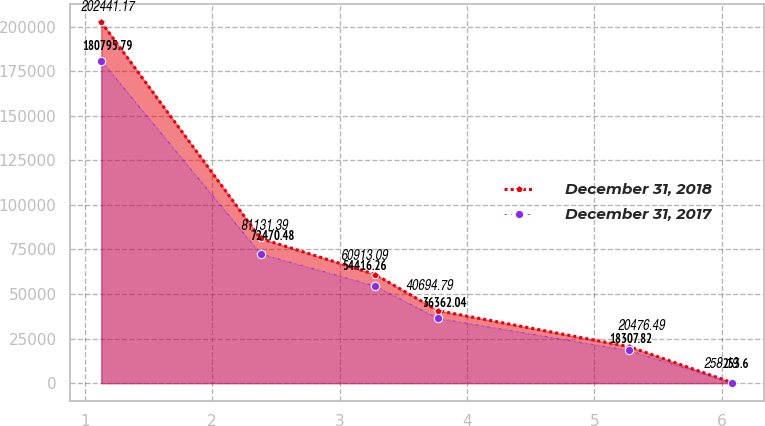Convert chart to OTSL. <chart><loc_0><loc_0><loc_500><loc_500><line_chart><ecel><fcel>December 31, 2018<fcel>December 31, 2017<nl><fcel>1.13<fcel>202441<fcel>180796<nl><fcel>2.38<fcel>81131.4<fcel>72470.5<nl><fcel>3.28<fcel>60913.1<fcel>54416.3<nl><fcel>3.77<fcel>40694.8<fcel>36362<nl><fcel>5.27<fcel>20476.5<fcel>18307.8<nl><fcel>6.08<fcel>258.19<fcel>253.6<nl></chart> 